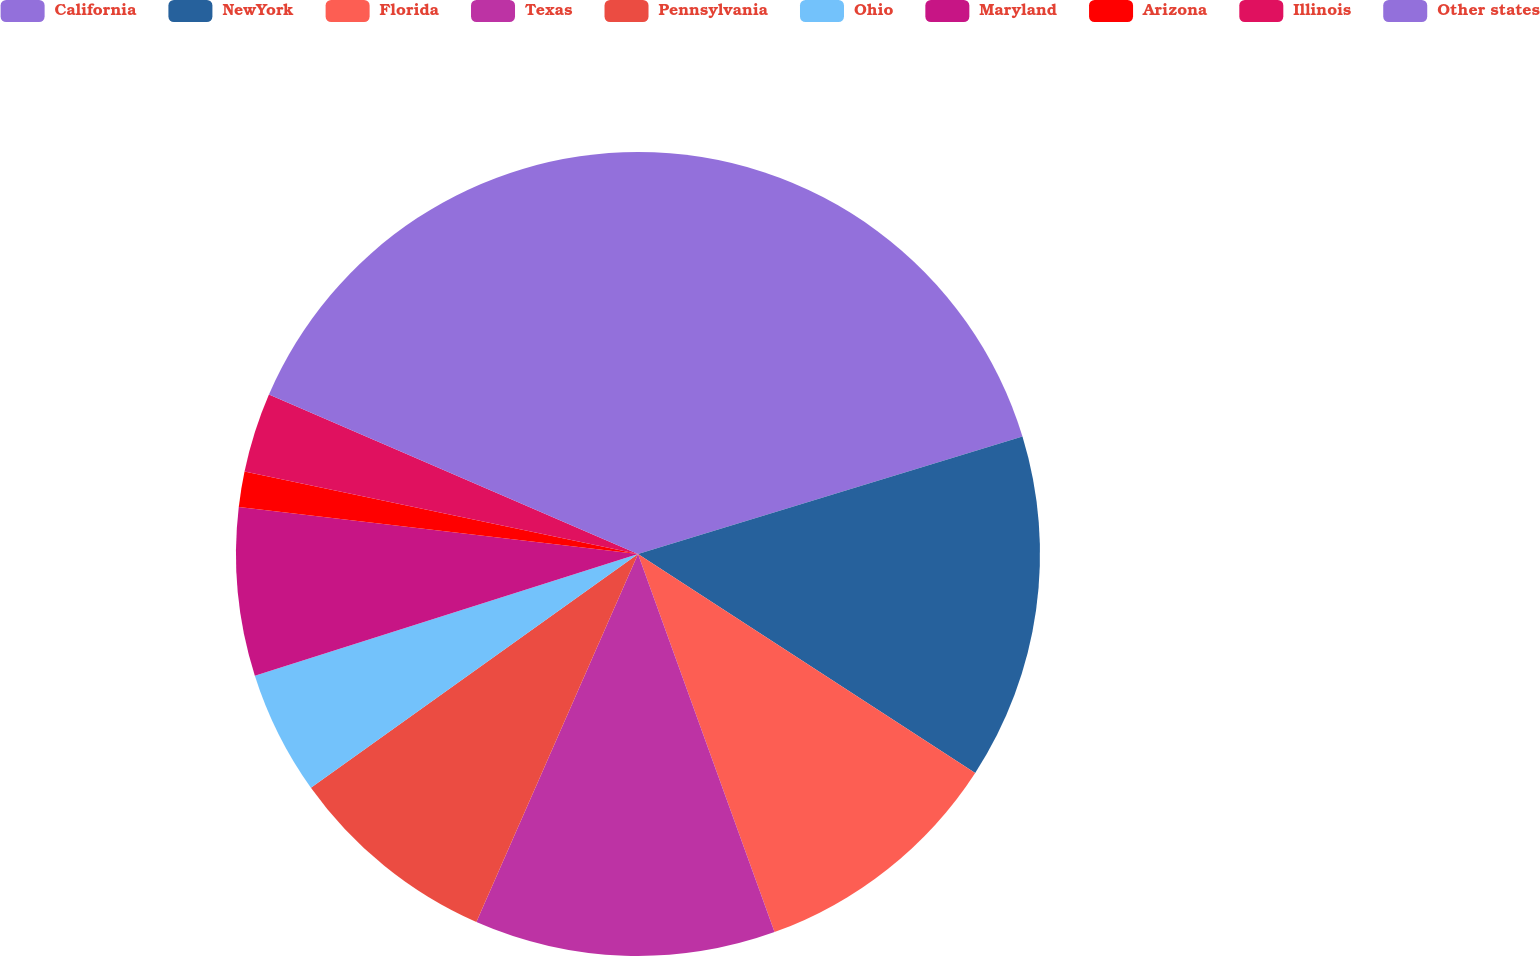<chart> <loc_0><loc_0><loc_500><loc_500><pie_chart><fcel>California<fcel>NewYork<fcel>Florida<fcel>Texas<fcel>Pennsylvania<fcel>Ohio<fcel>Maryland<fcel>Arizona<fcel>Illinois<fcel>Other states<nl><fcel>20.28%<fcel>13.88%<fcel>10.32%<fcel>12.1%<fcel>8.54%<fcel>4.98%<fcel>6.76%<fcel>1.42%<fcel>3.2%<fcel>18.51%<nl></chart> 